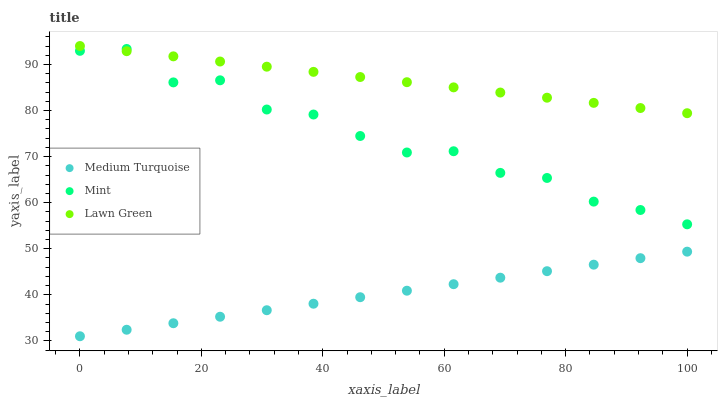Does Medium Turquoise have the minimum area under the curve?
Answer yes or no. Yes. Does Lawn Green have the maximum area under the curve?
Answer yes or no. Yes. Does Mint have the minimum area under the curve?
Answer yes or no. No. Does Mint have the maximum area under the curve?
Answer yes or no. No. Is Medium Turquoise the smoothest?
Answer yes or no. Yes. Is Mint the roughest?
Answer yes or no. Yes. Is Mint the smoothest?
Answer yes or no. No. Is Medium Turquoise the roughest?
Answer yes or no. No. Does Medium Turquoise have the lowest value?
Answer yes or no. Yes. Does Mint have the lowest value?
Answer yes or no. No. Does Lawn Green have the highest value?
Answer yes or no. Yes. Does Mint have the highest value?
Answer yes or no. No. Is Medium Turquoise less than Lawn Green?
Answer yes or no. Yes. Is Mint greater than Medium Turquoise?
Answer yes or no. Yes. Does Mint intersect Lawn Green?
Answer yes or no. Yes. Is Mint less than Lawn Green?
Answer yes or no. No. Is Mint greater than Lawn Green?
Answer yes or no. No. Does Medium Turquoise intersect Lawn Green?
Answer yes or no. No. 